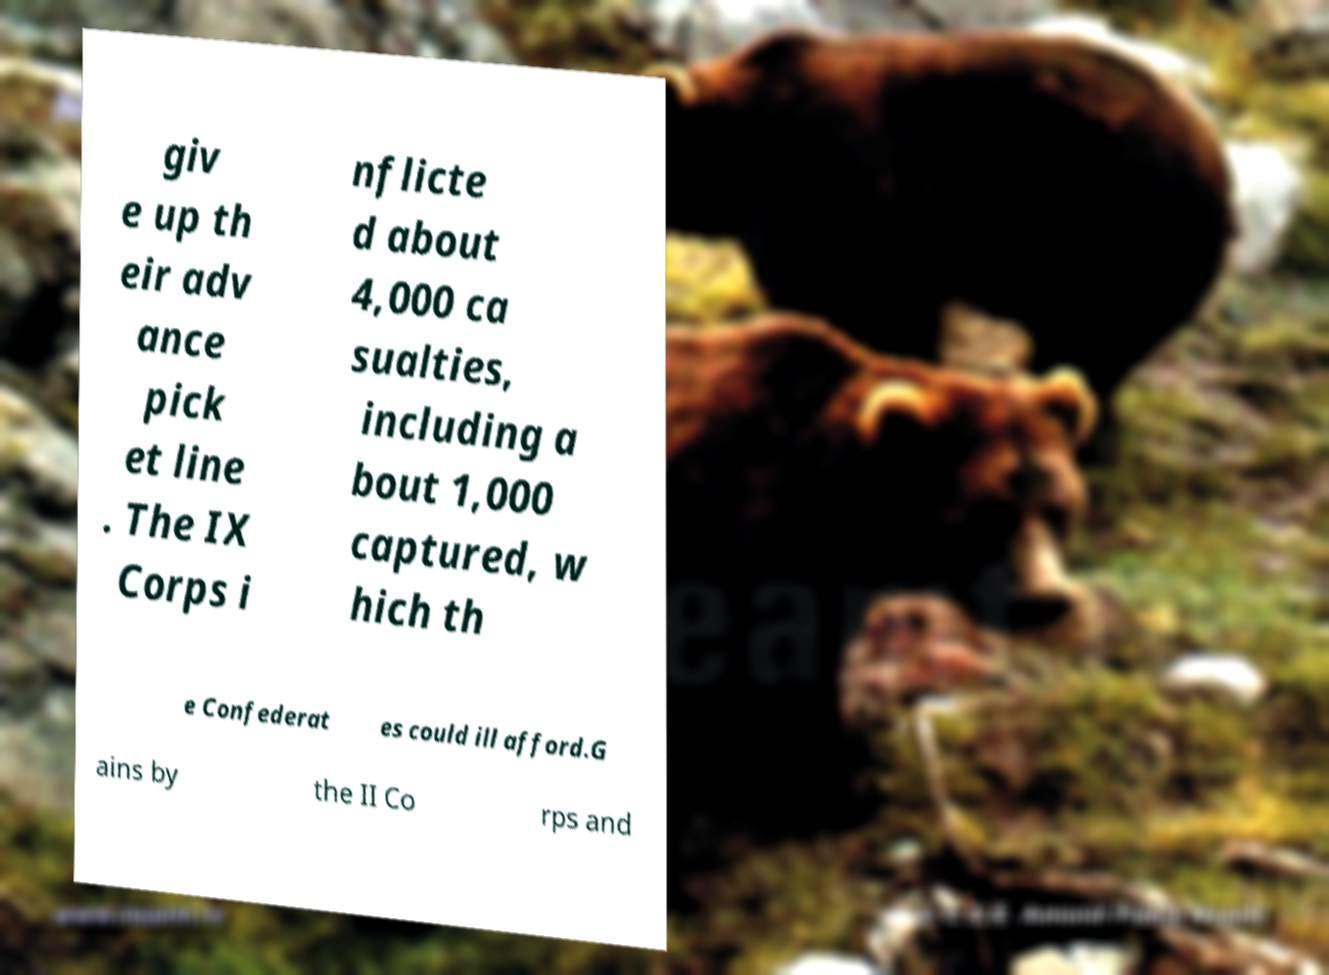Please identify and transcribe the text found in this image. giv e up th eir adv ance pick et line . The IX Corps i nflicte d about 4,000 ca sualties, including a bout 1,000 captured, w hich th e Confederat es could ill afford.G ains by the II Co rps and 